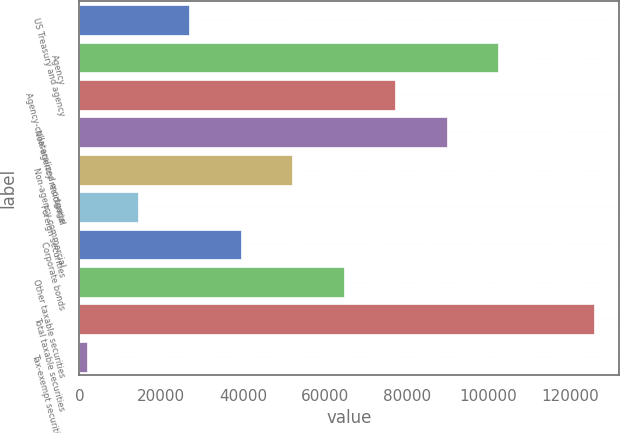Convert chart to OTSL. <chart><loc_0><loc_0><loc_500><loc_500><bar_chart><fcel>US Treasury and agency<fcel>Agency<fcel>Agency-collateralized mortgage<fcel>Non-agency residential<fcel>Non-agency commercial<fcel>Foreign securities<fcel>Corporate bonds<fcel>Other taxable securities<fcel>Total taxable securities<fcel>Tax-exempt securities (2)<nl><fcel>26908.8<fcel>102319<fcel>77182.4<fcel>89750.8<fcel>52045.6<fcel>14340.4<fcel>39477.2<fcel>64614<fcel>125684<fcel>1772<nl></chart> 